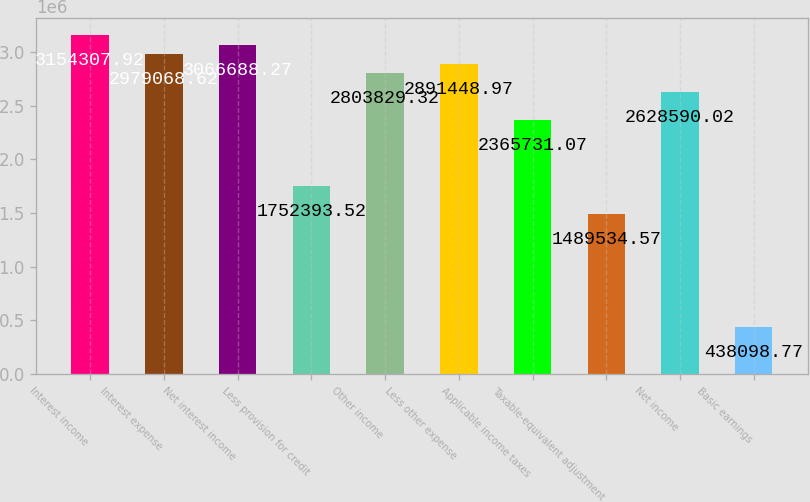<chart> <loc_0><loc_0><loc_500><loc_500><bar_chart><fcel>Interest income<fcel>Interest expense<fcel>Net interest income<fcel>Less provision for credit<fcel>Other income<fcel>Less other expense<fcel>Applicable income taxes<fcel>Taxable-equivalent adjustment<fcel>Net income<fcel>Basic earnings<nl><fcel>3.15431e+06<fcel>2.97907e+06<fcel>3.06669e+06<fcel>1.75239e+06<fcel>2.80383e+06<fcel>2.89145e+06<fcel>2.36573e+06<fcel>1.48953e+06<fcel>2.62859e+06<fcel>438099<nl></chart> 